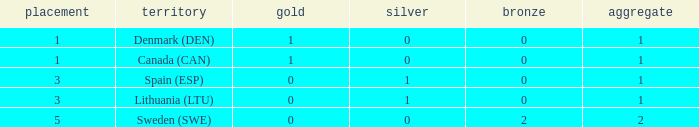How many bronze medals were won when the total is more than 1, and gold is more than 0? None. 